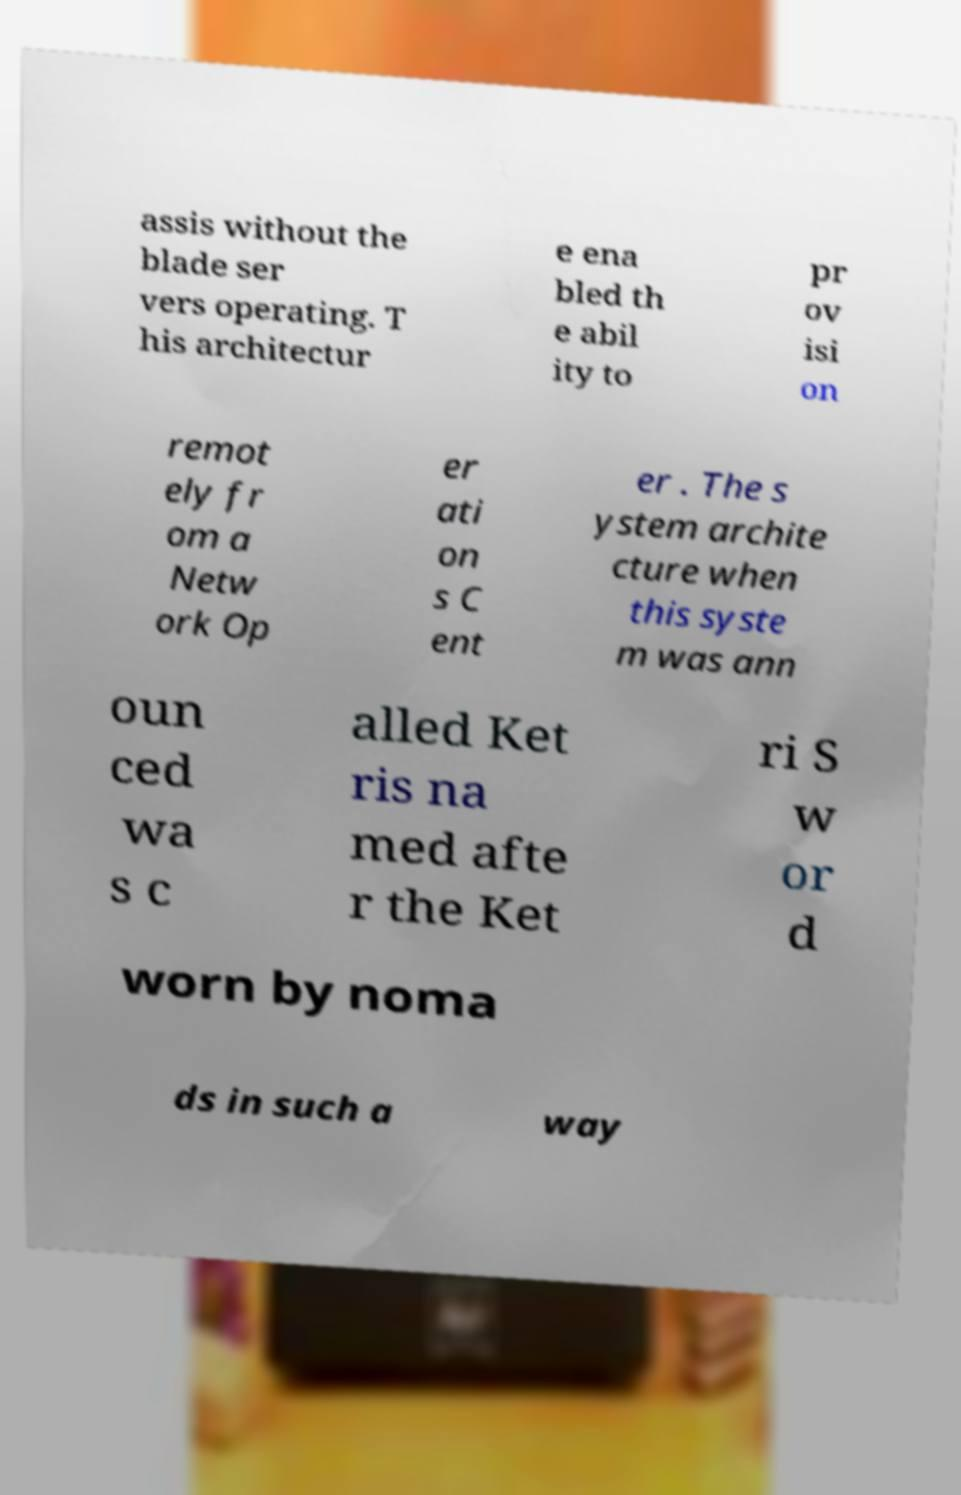What messages or text are displayed in this image? I need them in a readable, typed format. assis without the blade ser vers operating. T his architectur e ena bled th e abil ity to pr ov isi on remot ely fr om a Netw ork Op er ati on s C ent er . The s ystem archite cture when this syste m was ann oun ced wa s c alled Ket ris na med afte r the Ket ri S w or d worn by noma ds in such a way 